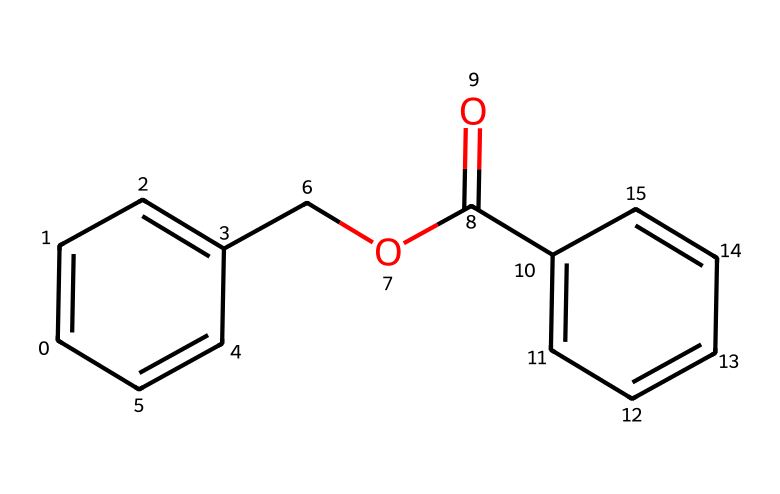What is the name of this chemical? The structure corresponds to the SMILES representation provided, which refers to benzyl benzoate, an ester formed from benzoic acid and benzyl alcohol.
Answer: benzyl benzoate How many carbon atoms are in the molecule? By analyzing the structure, we can count the carbon atoms in both the aromatic rings and the ester functional group. There are a total of 15 carbon atoms.
Answer: 15 What type of functional group is present in this chemical? The structure contains an ester group, identifiable by the -COOC- linkage present in its chemical backbone. This is specific to the ester classification.
Answer: ester Is benzyl benzoate polar or nonpolar? Considering the overall molecular structure, including the aromatic rings and the ester group, benzyl benzoate is less polar due to the nonpolar aromatic portions dominating.
Answer: nonpolar What are the two original compounds that form benzyl benzoate? Benzyl benzoate is the ester formed from benzoic acid and benzyl alcohol. Analyzing the structure shows the presence of these components.
Answer: benzoic acid and benzyl alcohol What is the molecular formula of benzyl benzoate? To derive the molecular formula from the structure, we combine the number of each type of atom, which results in C15H14O2 for benzyl benzoate.
Answer: C15H14O2 